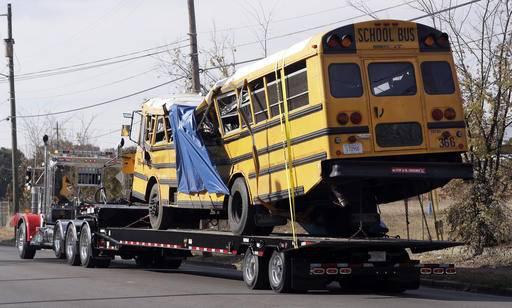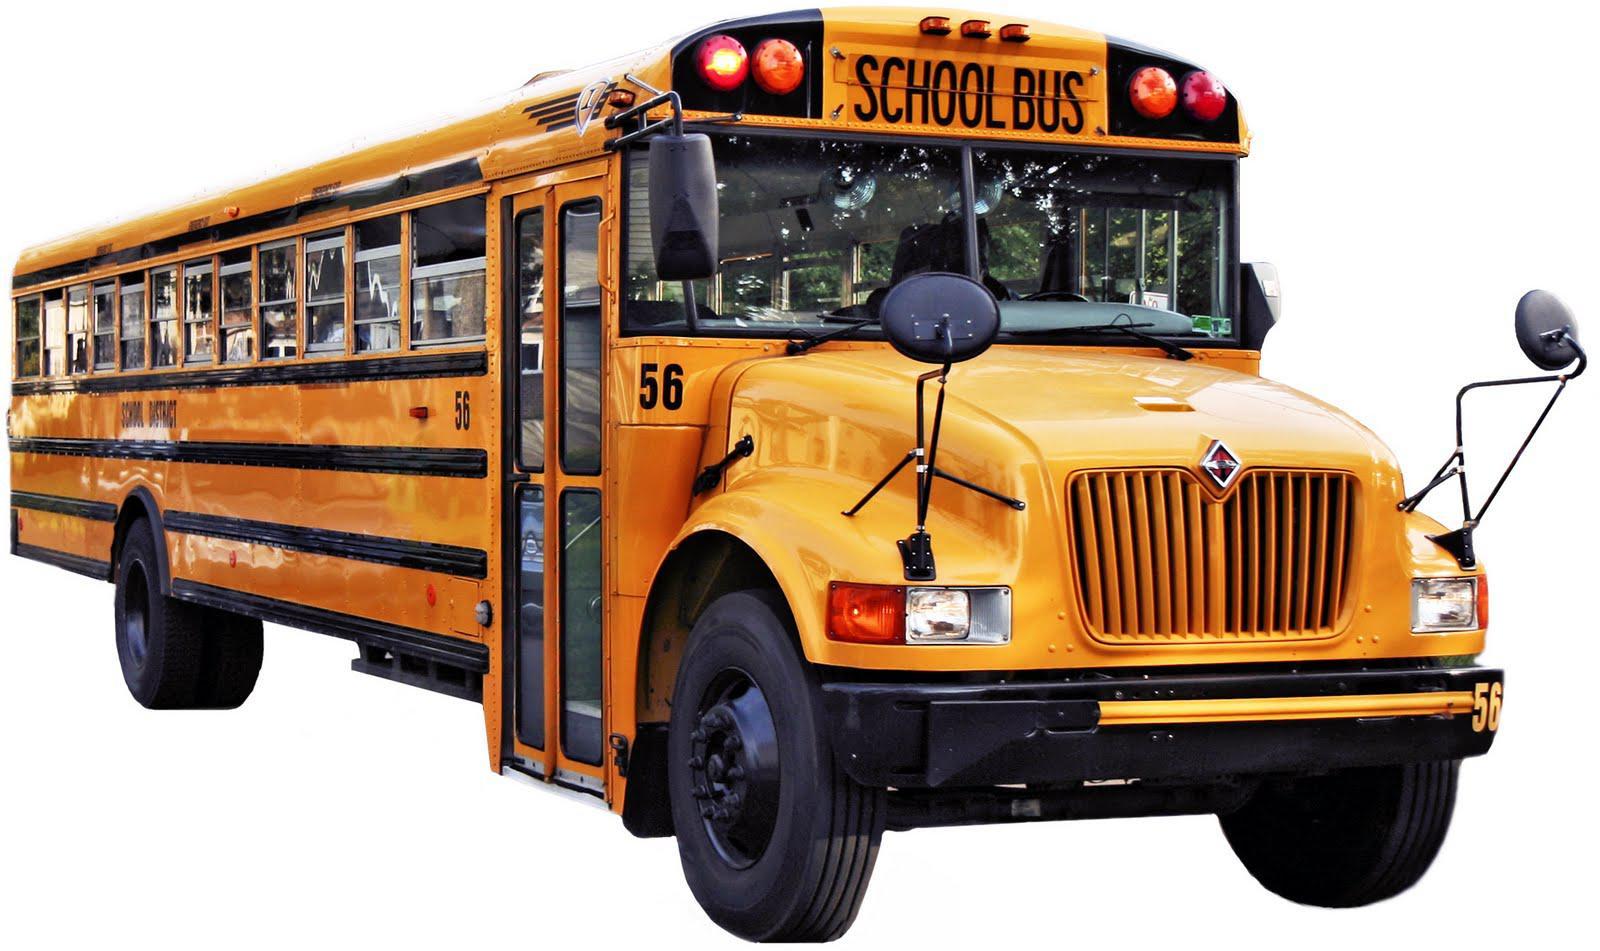The first image is the image on the left, the second image is the image on the right. Analyze the images presented: Is the assertion "The left and right image contains the same number of buses facing frontward and backward." valid? Answer yes or no. Yes. The first image is the image on the left, the second image is the image on the right. For the images displayed, is the sentence "An image shows a man standing to the left, and at least one child in front of the door of a flat-fronted school bus." factually correct? Answer yes or no. No. 